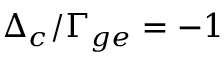Convert formula to latex. <formula><loc_0><loc_0><loc_500><loc_500>\Delta _ { c } / \Gamma _ { g e } = - 1</formula> 